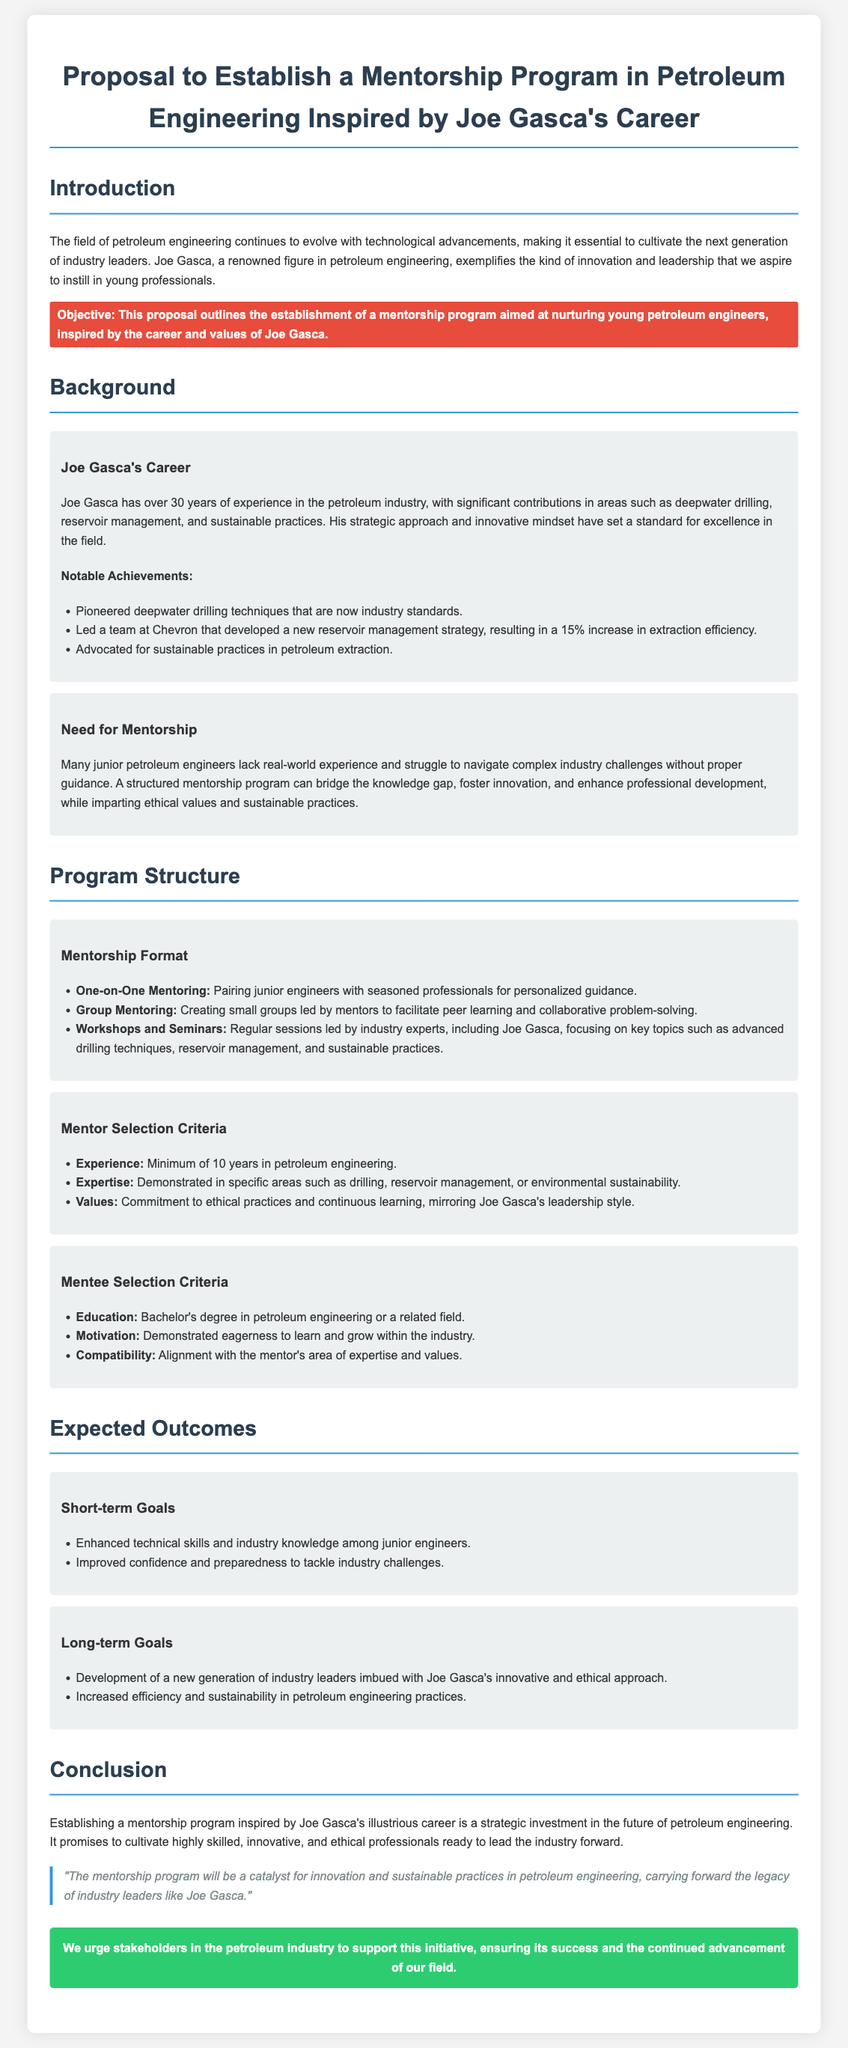What is the primary objective of the proposal? The objective is to establish a mentorship program aimed at nurturing young petroleum engineers, inspired by the career and values of Joe Gasca.
Answer: to establish a mentorship program How many years of experience does Joe Gasca have in the petroleum industry? The document states that Joe Gasca has over 30 years of experience in the petroleum industry.
Answer: 30 years What notable achievement is associated with Joe Gasca in the document? The document lists several achievements, one of which is pioneering deepwater drilling techniques that are now industry standards.
Answer: pioneered deepwater drilling techniques What is one short-term goal of the mentorship program? One short-term goal mentioned is enhanced technical skills and industry knowledge among junior engineers.
Answer: enhanced technical skills What should mentors demonstrate according to the mentor selection criteria? According to the document, mentors should demonstrate commitment to ethical practices and continuous learning, mirroring Joe Gasca's leadership style.
Answer: commitment to ethical practices What type of mentoring format involves small groups led by mentors? The document describes a group mentoring format that facilitates peer learning and collaborative problem-solving.
Answer: group mentoring What is the main focus of workshops and seminars in the program? The workshops and seminars focus on key topics such as advanced drilling techniques, reservoir management, and sustainable practices.
Answer: advanced drilling techniques Which industry figure is specifically mentioned as a potential workshop leader? The document highlights Joe Gasca as a notable figure who could lead workshops and seminars.
Answer: Joe Gasca 